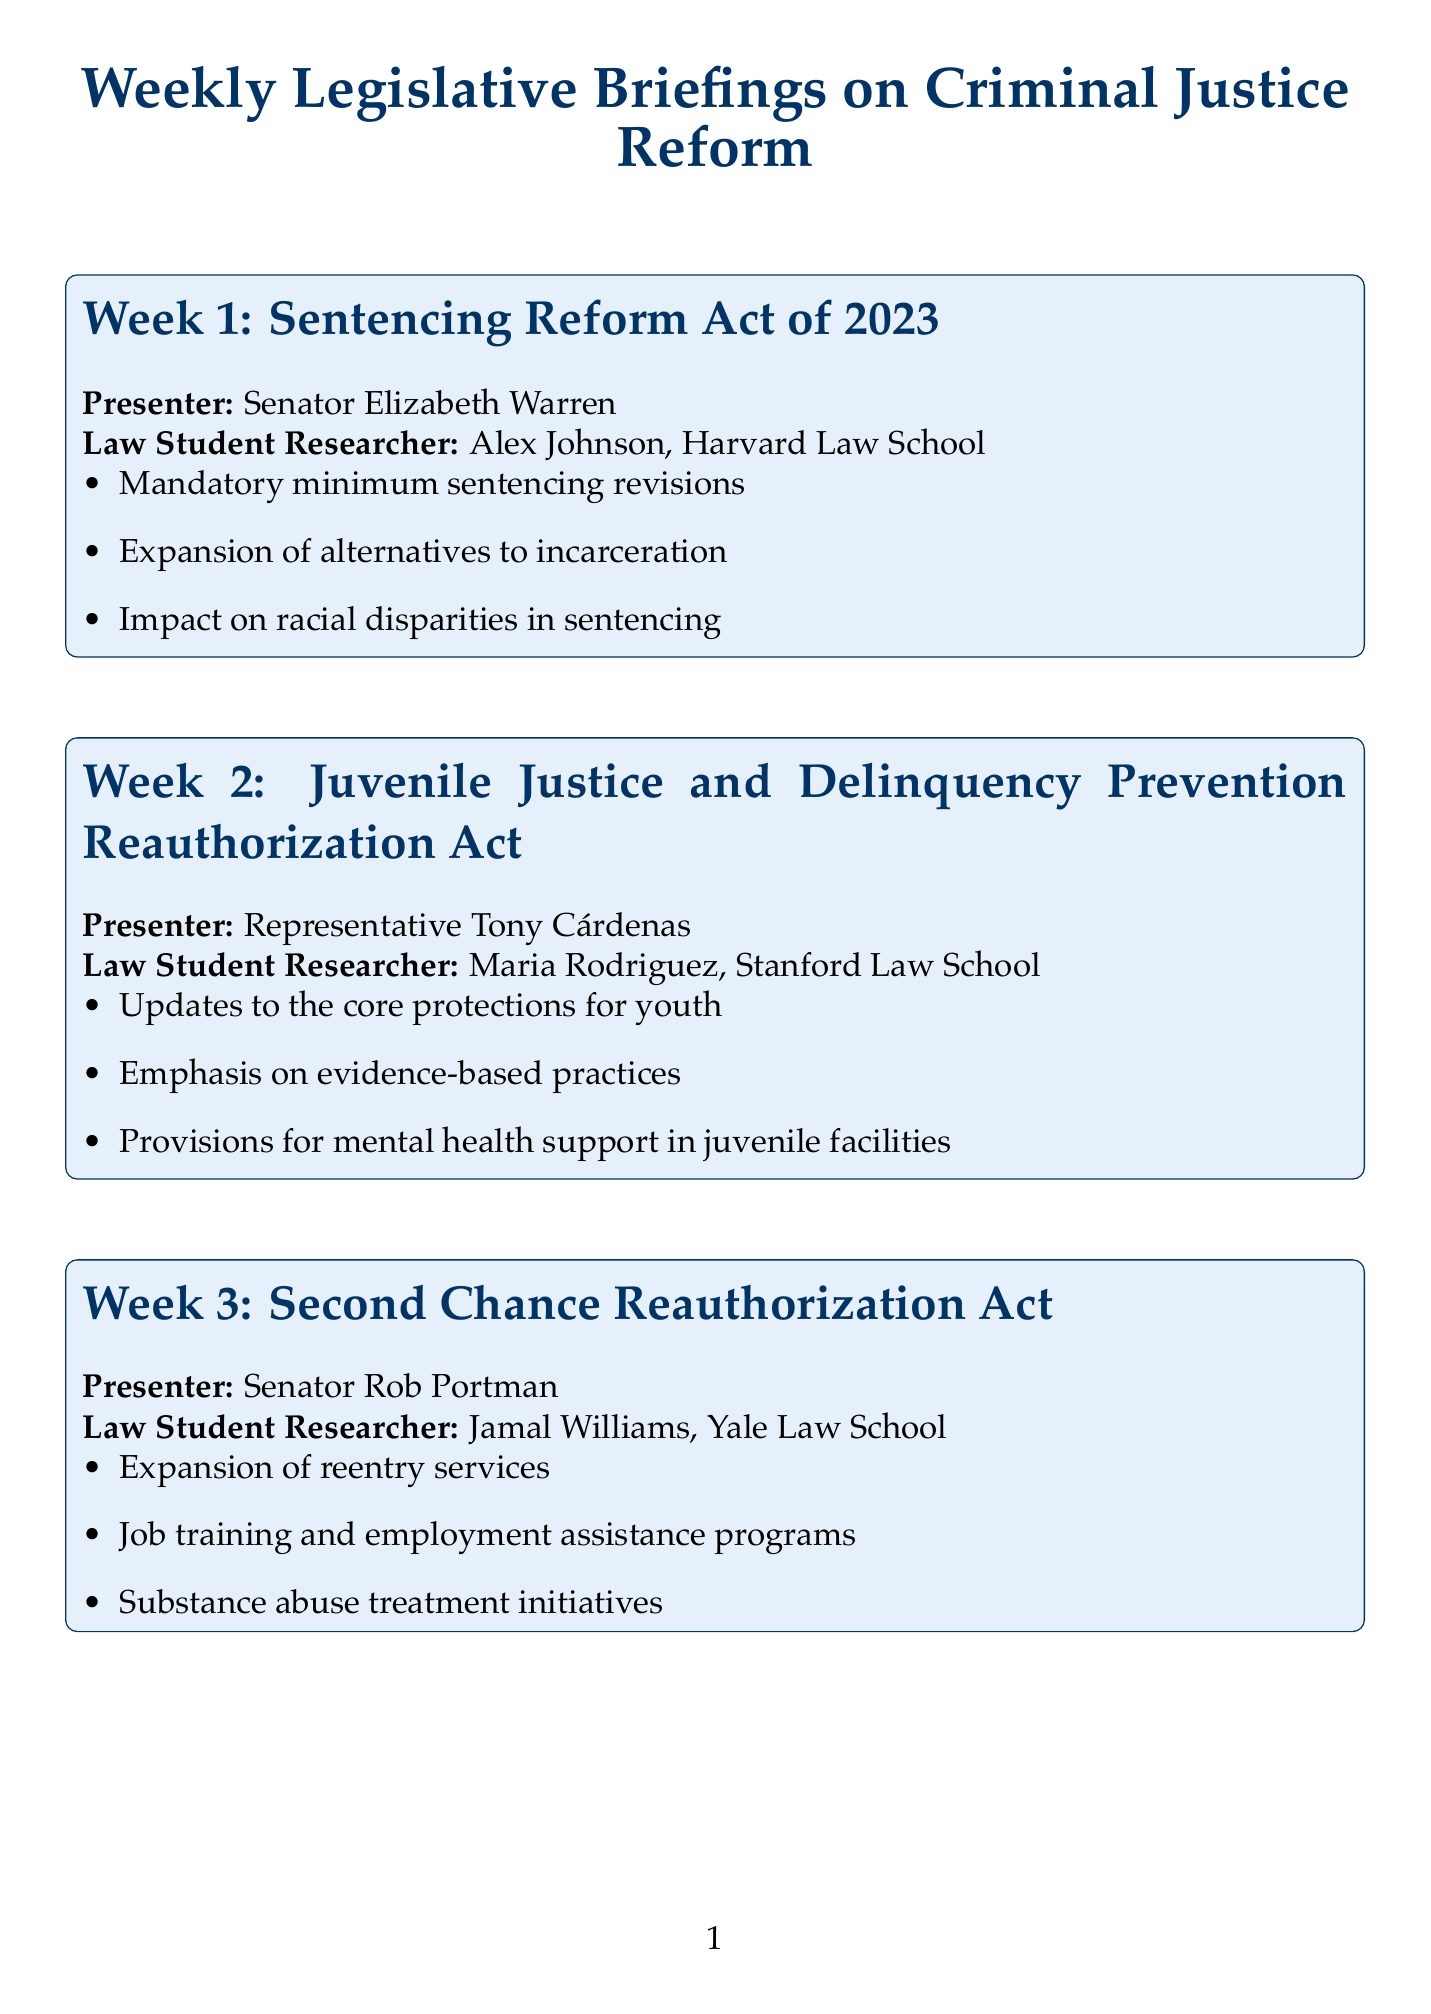What is the topic for Week 1? The topic listed for Week 1 is the "Sentencing Reform Act of 2023."
Answer: Sentencing Reform Act of 2023 Who presented the Juvenile Justice and Delinquency Prevention Reauthorization Act? The presenter of the Juvenile Justice and Delinquency Prevention Reauthorization Act is Representative Tony Cárdenas.
Answer: Representative Tony Cárdenas Which law student researcher focused on the Second Chance Reauthorization Act? The law student researcher for the Second Chance Reauthorization Act is Jamal Williams from Yale Law School.
Answer: Jamal Williams, Yale Law School What key point addresses racial disparities in Week 1? The key point that addresses racial disparities in Week 1 is "Impact on racial disparities in sentencing."
Answer: Impact on racial disparities in sentencing How many weeks are covered in the legislative briefings? The document covers a total of six weeks of legislative briefings.
Answer: 6 What is a key point from the Police Accountability and Community Engagement Act? A key point from the Police Accountability and Community Engagement Act is "Mandatory body camera usage policies."
Answer: Mandatory body camera usage policies What common theme can be identified across the bills presented? The common theme is focusing on reforming aspects of criminal justice and improving community and individual support.
Answer: Reforming aspects of criminal justice What is the primary focus of the Correctional Education and Vocational Training Act? The primary focus is on the expansion of educational programs in prisons.
Answer: Expansion of educational programs in prisons Which law student researcher presented on the Bail Reform Act of 2023? The law student researcher who presented on the Bail Reform Act of 2023 is Emily Chen, Columbia Law School.
Answer: Emily Chen, Columbia Law School 